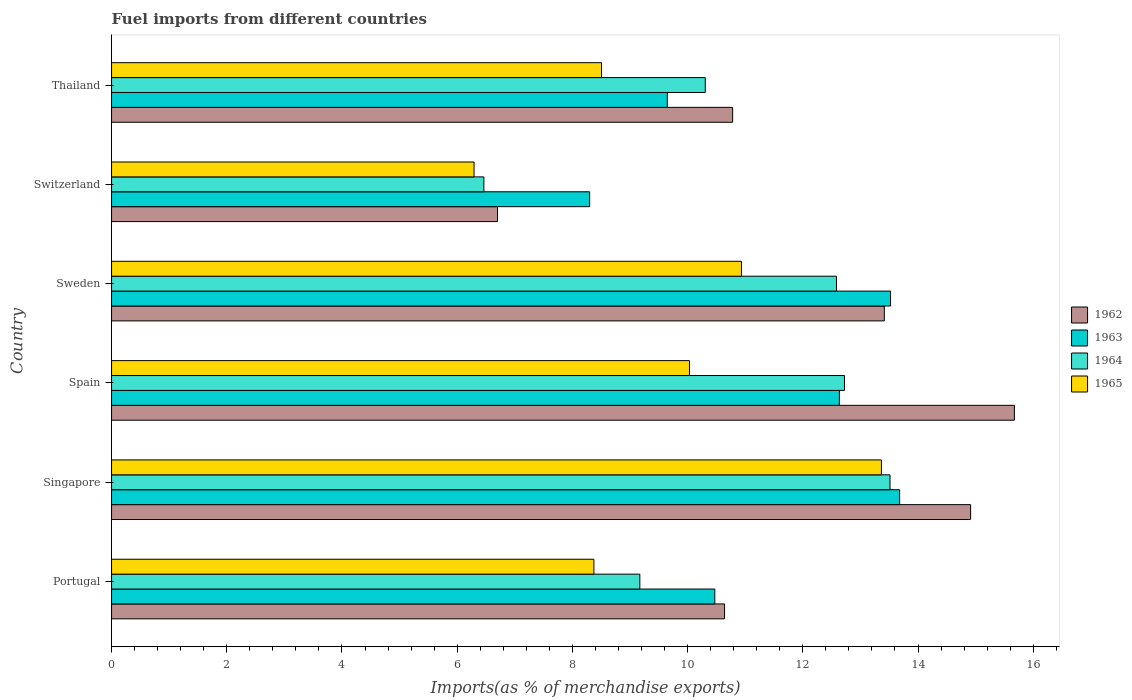How many different coloured bars are there?
Your answer should be compact. 4. Are the number of bars per tick equal to the number of legend labels?
Offer a terse response. Yes. How many bars are there on the 3rd tick from the top?
Offer a terse response. 4. How many bars are there on the 4th tick from the bottom?
Your answer should be compact. 4. What is the label of the 2nd group of bars from the top?
Your response must be concise. Switzerland. What is the percentage of imports to different countries in 1964 in Sweden?
Your response must be concise. 12.58. Across all countries, what is the maximum percentage of imports to different countries in 1962?
Your answer should be very brief. 15.67. Across all countries, what is the minimum percentage of imports to different countries in 1965?
Your answer should be very brief. 6.29. In which country was the percentage of imports to different countries in 1964 maximum?
Provide a short and direct response. Singapore. In which country was the percentage of imports to different countries in 1962 minimum?
Ensure brevity in your answer.  Switzerland. What is the total percentage of imports to different countries in 1964 in the graph?
Give a very brief answer. 64.76. What is the difference between the percentage of imports to different countries in 1963 in Portugal and that in Singapore?
Make the answer very short. -3.21. What is the difference between the percentage of imports to different countries in 1965 in Switzerland and the percentage of imports to different countries in 1964 in Singapore?
Offer a very short reply. -7.22. What is the average percentage of imports to different countries in 1962 per country?
Ensure brevity in your answer.  12.02. What is the difference between the percentage of imports to different countries in 1964 and percentage of imports to different countries in 1963 in Switzerland?
Keep it short and to the point. -1.84. In how many countries, is the percentage of imports to different countries in 1962 greater than 7.2 %?
Offer a very short reply. 5. What is the ratio of the percentage of imports to different countries in 1964 in Singapore to that in Thailand?
Give a very brief answer. 1.31. What is the difference between the highest and the second highest percentage of imports to different countries in 1965?
Provide a succinct answer. 2.43. What is the difference between the highest and the lowest percentage of imports to different countries in 1965?
Keep it short and to the point. 7.07. What does the 4th bar from the bottom in Sweden represents?
Your response must be concise. 1965. Is it the case that in every country, the sum of the percentage of imports to different countries in 1963 and percentage of imports to different countries in 1965 is greater than the percentage of imports to different countries in 1962?
Make the answer very short. Yes. Are all the bars in the graph horizontal?
Keep it short and to the point. Yes. Does the graph contain any zero values?
Offer a terse response. No. Does the graph contain grids?
Offer a terse response. No. Where does the legend appear in the graph?
Offer a very short reply. Center right. What is the title of the graph?
Keep it short and to the point. Fuel imports from different countries. Does "2003" appear as one of the legend labels in the graph?
Your answer should be compact. No. What is the label or title of the X-axis?
Offer a very short reply. Imports(as % of merchandise exports). What is the label or title of the Y-axis?
Keep it short and to the point. Country. What is the Imports(as % of merchandise exports) in 1962 in Portugal?
Your answer should be compact. 10.64. What is the Imports(as % of merchandise exports) of 1963 in Portugal?
Offer a very short reply. 10.47. What is the Imports(as % of merchandise exports) in 1964 in Portugal?
Ensure brevity in your answer.  9.17. What is the Imports(as % of merchandise exports) in 1965 in Portugal?
Offer a very short reply. 8.37. What is the Imports(as % of merchandise exports) of 1962 in Singapore?
Give a very brief answer. 14.91. What is the Imports(as % of merchandise exports) of 1963 in Singapore?
Your response must be concise. 13.68. What is the Imports(as % of merchandise exports) in 1964 in Singapore?
Provide a short and direct response. 13.51. What is the Imports(as % of merchandise exports) of 1965 in Singapore?
Provide a succinct answer. 13.37. What is the Imports(as % of merchandise exports) in 1962 in Spain?
Offer a very short reply. 15.67. What is the Imports(as % of merchandise exports) in 1963 in Spain?
Give a very brief answer. 12.64. What is the Imports(as % of merchandise exports) in 1964 in Spain?
Your answer should be very brief. 12.72. What is the Imports(as % of merchandise exports) in 1965 in Spain?
Your answer should be very brief. 10.03. What is the Imports(as % of merchandise exports) in 1962 in Sweden?
Your answer should be compact. 13.42. What is the Imports(as % of merchandise exports) in 1963 in Sweden?
Ensure brevity in your answer.  13.52. What is the Imports(as % of merchandise exports) of 1964 in Sweden?
Provide a short and direct response. 12.58. What is the Imports(as % of merchandise exports) of 1965 in Sweden?
Ensure brevity in your answer.  10.93. What is the Imports(as % of merchandise exports) in 1962 in Switzerland?
Give a very brief answer. 6.7. What is the Imports(as % of merchandise exports) of 1963 in Switzerland?
Provide a short and direct response. 8.3. What is the Imports(as % of merchandise exports) of 1964 in Switzerland?
Keep it short and to the point. 6.46. What is the Imports(as % of merchandise exports) of 1965 in Switzerland?
Provide a short and direct response. 6.29. What is the Imports(as % of merchandise exports) of 1962 in Thailand?
Keep it short and to the point. 10.78. What is the Imports(as % of merchandise exports) in 1963 in Thailand?
Your response must be concise. 9.65. What is the Imports(as % of merchandise exports) in 1964 in Thailand?
Offer a terse response. 10.31. What is the Imports(as % of merchandise exports) in 1965 in Thailand?
Give a very brief answer. 8.51. Across all countries, what is the maximum Imports(as % of merchandise exports) of 1962?
Offer a very short reply. 15.67. Across all countries, what is the maximum Imports(as % of merchandise exports) of 1963?
Provide a succinct answer. 13.68. Across all countries, what is the maximum Imports(as % of merchandise exports) in 1964?
Offer a terse response. 13.51. Across all countries, what is the maximum Imports(as % of merchandise exports) of 1965?
Offer a very short reply. 13.37. Across all countries, what is the minimum Imports(as % of merchandise exports) in 1962?
Offer a very short reply. 6.7. Across all countries, what is the minimum Imports(as % of merchandise exports) in 1963?
Provide a short and direct response. 8.3. Across all countries, what is the minimum Imports(as % of merchandise exports) of 1964?
Your answer should be compact. 6.46. Across all countries, what is the minimum Imports(as % of merchandise exports) of 1965?
Make the answer very short. 6.29. What is the total Imports(as % of merchandise exports) in 1962 in the graph?
Offer a very short reply. 72.13. What is the total Imports(as % of merchandise exports) in 1963 in the graph?
Your answer should be very brief. 68.26. What is the total Imports(as % of merchandise exports) of 1964 in the graph?
Your answer should be compact. 64.76. What is the total Imports(as % of merchandise exports) in 1965 in the graph?
Ensure brevity in your answer.  57.51. What is the difference between the Imports(as % of merchandise exports) of 1962 in Portugal and that in Singapore?
Offer a terse response. -4.27. What is the difference between the Imports(as % of merchandise exports) in 1963 in Portugal and that in Singapore?
Your answer should be very brief. -3.21. What is the difference between the Imports(as % of merchandise exports) in 1964 in Portugal and that in Singapore?
Provide a succinct answer. -4.34. What is the difference between the Imports(as % of merchandise exports) of 1965 in Portugal and that in Singapore?
Make the answer very short. -4.99. What is the difference between the Imports(as % of merchandise exports) of 1962 in Portugal and that in Spain?
Provide a short and direct response. -5.03. What is the difference between the Imports(as % of merchandise exports) in 1963 in Portugal and that in Spain?
Your answer should be compact. -2.16. What is the difference between the Imports(as % of merchandise exports) of 1964 in Portugal and that in Spain?
Offer a terse response. -3.55. What is the difference between the Imports(as % of merchandise exports) in 1965 in Portugal and that in Spain?
Your response must be concise. -1.66. What is the difference between the Imports(as % of merchandise exports) in 1962 in Portugal and that in Sweden?
Provide a short and direct response. -2.77. What is the difference between the Imports(as % of merchandise exports) in 1963 in Portugal and that in Sweden?
Give a very brief answer. -3.05. What is the difference between the Imports(as % of merchandise exports) in 1964 in Portugal and that in Sweden?
Your response must be concise. -3.41. What is the difference between the Imports(as % of merchandise exports) in 1965 in Portugal and that in Sweden?
Give a very brief answer. -2.56. What is the difference between the Imports(as % of merchandise exports) in 1962 in Portugal and that in Switzerland?
Provide a short and direct response. 3.94. What is the difference between the Imports(as % of merchandise exports) of 1963 in Portugal and that in Switzerland?
Offer a very short reply. 2.17. What is the difference between the Imports(as % of merchandise exports) in 1964 in Portugal and that in Switzerland?
Make the answer very short. 2.71. What is the difference between the Imports(as % of merchandise exports) in 1965 in Portugal and that in Switzerland?
Ensure brevity in your answer.  2.08. What is the difference between the Imports(as % of merchandise exports) of 1962 in Portugal and that in Thailand?
Offer a terse response. -0.14. What is the difference between the Imports(as % of merchandise exports) in 1963 in Portugal and that in Thailand?
Provide a succinct answer. 0.82. What is the difference between the Imports(as % of merchandise exports) of 1964 in Portugal and that in Thailand?
Ensure brevity in your answer.  -1.14. What is the difference between the Imports(as % of merchandise exports) of 1965 in Portugal and that in Thailand?
Keep it short and to the point. -0.13. What is the difference between the Imports(as % of merchandise exports) in 1962 in Singapore and that in Spain?
Your answer should be very brief. -0.76. What is the difference between the Imports(as % of merchandise exports) in 1963 in Singapore and that in Spain?
Provide a short and direct response. 1.05. What is the difference between the Imports(as % of merchandise exports) of 1964 in Singapore and that in Spain?
Give a very brief answer. 0.79. What is the difference between the Imports(as % of merchandise exports) in 1965 in Singapore and that in Spain?
Your response must be concise. 3.33. What is the difference between the Imports(as % of merchandise exports) in 1962 in Singapore and that in Sweden?
Ensure brevity in your answer.  1.5. What is the difference between the Imports(as % of merchandise exports) in 1963 in Singapore and that in Sweden?
Offer a very short reply. 0.16. What is the difference between the Imports(as % of merchandise exports) in 1964 in Singapore and that in Sweden?
Give a very brief answer. 0.93. What is the difference between the Imports(as % of merchandise exports) in 1965 in Singapore and that in Sweden?
Keep it short and to the point. 2.43. What is the difference between the Imports(as % of merchandise exports) in 1962 in Singapore and that in Switzerland?
Your response must be concise. 8.21. What is the difference between the Imports(as % of merchandise exports) in 1963 in Singapore and that in Switzerland?
Provide a succinct answer. 5.38. What is the difference between the Imports(as % of merchandise exports) of 1964 in Singapore and that in Switzerland?
Your answer should be very brief. 7.05. What is the difference between the Imports(as % of merchandise exports) of 1965 in Singapore and that in Switzerland?
Make the answer very short. 7.07. What is the difference between the Imports(as % of merchandise exports) of 1962 in Singapore and that in Thailand?
Provide a short and direct response. 4.13. What is the difference between the Imports(as % of merchandise exports) of 1963 in Singapore and that in Thailand?
Make the answer very short. 4.03. What is the difference between the Imports(as % of merchandise exports) of 1964 in Singapore and that in Thailand?
Your answer should be compact. 3.21. What is the difference between the Imports(as % of merchandise exports) in 1965 in Singapore and that in Thailand?
Ensure brevity in your answer.  4.86. What is the difference between the Imports(as % of merchandise exports) in 1962 in Spain and that in Sweden?
Provide a short and direct response. 2.26. What is the difference between the Imports(as % of merchandise exports) of 1963 in Spain and that in Sweden?
Your response must be concise. -0.89. What is the difference between the Imports(as % of merchandise exports) in 1964 in Spain and that in Sweden?
Ensure brevity in your answer.  0.14. What is the difference between the Imports(as % of merchandise exports) of 1965 in Spain and that in Sweden?
Make the answer very short. -0.9. What is the difference between the Imports(as % of merchandise exports) of 1962 in Spain and that in Switzerland?
Make the answer very short. 8.97. What is the difference between the Imports(as % of merchandise exports) in 1963 in Spain and that in Switzerland?
Provide a short and direct response. 4.34. What is the difference between the Imports(as % of merchandise exports) of 1964 in Spain and that in Switzerland?
Ensure brevity in your answer.  6.26. What is the difference between the Imports(as % of merchandise exports) of 1965 in Spain and that in Switzerland?
Keep it short and to the point. 3.74. What is the difference between the Imports(as % of merchandise exports) in 1962 in Spain and that in Thailand?
Offer a very short reply. 4.89. What is the difference between the Imports(as % of merchandise exports) in 1963 in Spain and that in Thailand?
Provide a succinct answer. 2.99. What is the difference between the Imports(as % of merchandise exports) of 1964 in Spain and that in Thailand?
Offer a terse response. 2.42. What is the difference between the Imports(as % of merchandise exports) of 1965 in Spain and that in Thailand?
Make the answer very short. 1.53. What is the difference between the Imports(as % of merchandise exports) in 1962 in Sweden and that in Switzerland?
Keep it short and to the point. 6.72. What is the difference between the Imports(as % of merchandise exports) in 1963 in Sweden and that in Switzerland?
Give a very brief answer. 5.22. What is the difference between the Imports(as % of merchandise exports) of 1964 in Sweden and that in Switzerland?
Make the answer very short. 6.12. What is the difference between the Imports(as % of merchandise exports) of 1965 in Sweden and that in Switzerland?
Your answer should be very brief. 4.64. What is the difference between the Imports(as % of merchandise exports) in 1962 in Sweden and that in Thailand?
Offer a very short reply. 2.63. What is the difference between the Imports(as % of merchandise exports) in 1963 in Sweden and that in Thailand?
Your answer should be very brief. 3.88. What is the difference between the Imports(as % of merchandise exports) in 1964 in Sweden and that in Thailand?
Offer a very short reply. 2.28. What is the difference between the Imports(as % of merchandise exports) in 1965 in Sweden and that in Thailand?
Keep it short and to the point. 2.43. What is the difference between the Imports(as % of merchandise exports) of 1962 in Switzerland and that in Thailand?
Make the answer very short. -4.08. What is the difference between the Imports(as % of merchandise exports) in 1963 in Switzerland and that in Thailand?
Provide a short and direct response. -1.35. What is the difference between the Imports(as % of merchandise exports) in 1964 in Switzerland and that in Thailand?
Provide a succinct answer. -3.84. What is the difference between the Imports(as % of merchandise exports) in 1965 in Switzerland and that in Thailand?
Offer a terse response. -2.21. What is the difference between the Imports(as % of merchandise exports) of 1962 in Portugal and the Imports(as % of merchandise exports) of 1963 in Singapore?
Your response must be concise. -3.04. What is the difference between the Imports(as % of merchandise exports) in 1962 in Portugal and the Imports(as % of merchandise exports) in 1964 in Singapore?
Keep it short and to the point. -2.87. What is the difference between the Imports(as % of merchandise exports) of 1962 in Portugal and the Imports(as % of merchandise exports) of 1965 in Singapore?
Give a very brief answer. -2.72. What is the difference between the Imports(as % of merchandise exports) in 1963 in Portugal and the Imports(as % of merchandise exports) in 1964 in Singapore?
Make the answer very short. -3.04. What is the difference between the Imports(as % of merchandise exports) in 1963 in Portugal and the Imports(as % of merchandise exports) in 1965 in Singapore?
Offer a very short reply. -2.89. What is the difference between the Imports(as % of merchandise exports) in 1964 in Portugal and the Imports(as % of merchandise exports) in 1965 in Singapore?
Provide a short and direct response. -4.19. What is the difference between the Imports(as % of merchandise exports) of 1962 in Portugal and the Imports(as % of merchandise exports) of 1963 in Spain?
Your answer should be very brief. -1.99. What is the difference between the Imports(as % of merchandise exports) of 1962 in Portugal and the Imports(as % of merchandise exports) of 1964 in Spain?
Keep it short and to the point. -2.08. What is the difference between the Imports(as % of merchandise exports) of 1962 in Portugal and the Imports(as % of merchandise exports) of 1965 in Spain?
Offer a terse response. 0.61. What is the difference between the Imports(as % of merchandise exports) of 1963 in Portugal and the Imports(as % of merchandise exports) of 1964 in Spain?
Your response must be concise. -2.25. What is the difference between the Imports(as % of merchandise exports) of 1963 in Portugal and the Imports(as % of merchandise exports) of 1965 in Spain?
Give a very brief answer. 0.44. What is the difference between the Imports(as % of merchandise exports) of 1964 in Portugal and the Imports(as % of merchandise exports) of 1965 in Spain?
Keep it short and to the point. -0.86. What is the difference between the Imports(as % of merchandise exports) of 1962 in Portugal and the Imports(as % of merchandise exports) of 1963 in Sweden?
Provide a short and direct response. -2.88. What is the difference between the Imports(as % of merchandise exports) of 1962 in Portugal and the Imports(as % of merchandise exports) of 1964 in Sweden?
Your response must be concise. -1.94. What is the difference between the Imports(as % of merchandise exports) of 1962 in Portugal and the Imports(as % of merchandise exports) of 1965 in Sweden?
Provide a succinct answer. -0.29. What is the difference between the Imports(as % of merchandise exports) of 1963 in Portugal and the Imports(as % of merchandise exports) of 1964 in Sweden?
Ensure brevity in your answer.  -2.11. What is the difference between the Imports(as % of merchandise exports) in 1963 in Portugal and the Imports(as % of merchandise exports) in 1965 in Sweden?
Provide a short and direct response. -0.46. What is the difference between the Imports(as % of merchandise exports) of 1964 in Portugal and the Imports(as % of merchandise exports) of 1965 in Sweden?
Offer a terse response. -1.76. What is the difference between the Imports(as % of merchandise exports) in 1962 in Portugal and the Imports(as % of merchandise exports) in 1963 in Switzerland?
Your response must be concise. 2.34. What is the difference between the Imports(as % of merchandise exports) in 1962 in Portugal and the Imports(as % of merchandise exports) in 1964 in Switzerland?
Your answer should be compact. 4.18. What is the difference between the Imports(as % of merchandise exports) of 1962 in Portugal and the Imports(as % of merchandise exports) of 1965 in Switzerland?
Ensure brevity in your answer.  4.35. What is the difference between the Imports(as % of merchandise exports) in 1963 in Portugal and the Imports(as % of merchandise exports) in 1964 in Switzerland?
Your answer should be very brief. 4.01. What is the difference between the Imports(as % of merchandise exports) in 1963 in Portugal and the Imports(as % of merchandise exports) in 1965 in Switzerland?
Provide a succinct answer. 4.18. What is the difference between the Imports(as % of merchandise exports) in 1964 in Portugal and the Imports(as % of merchandise exports) in 1965 in Switzerland?
Offer a very short reply. 2.88. What is the difference between the Imports(as % of merchandise exports) in 1962 in Portugal and the Imports(as % of merchandise exports) in 1964 in Thailand?
Ensure brevity in your answer.  0.33. What is the difference between the Imports(as % of merchandise exports) of 1962 in Portugal and the Imports(as % of merchandise exports) of 1965 in Thailand?
Provide a short and direct response. 2.14. What is the difference between the Imports(as % of merchandise exports) in 1963 in Portugal and the Imports(as % of merchandise exports) in 1964 in Thailand?
Provide a succinct answer. 0.17. What is the difference between the Imports(as % of merchandise exports) of 1963 in Portugal and the Imports(as % of merchandise exports) of 1965 in Thailand?
Keep it short and to the point. 1.97. What is the difference between the Imports(as % of merchandise exports) of 1964 in Portugal and the Imports(as % of merchandise exports) of 1965 in Thailand?
Make the answer very short. 0.66. What is the difference between the Imports(as % of merchandise exports) of 1962 in Singapore and the Imports(as % of merchandise exports) of 1963 in Spain?
Ensure brevity in your answer.  2.28. What is the difference between the Imports(as % of merchandise exports) in 1962 in Singapore and the Imports(as % of merchandise exports) in 1964 in Spain?
Your answer should be compact. 2.19. What is the difference between the Imports(as % of merchandise exports) of 1962 in Singapore and the Imports(as % of merchandise exports) of 1965 in Spain?
Provide a succinct answer. 4.88. What is the difference between the Imports(as % of merchandise exports) in 1963 in Singapore and the Imports(as % of merchandise exports) in 1964 in Spain?
Your answer should be compact. 0.96. What is the difference between the Imports(as % of merchandise exports) of 1963 in Singapore and the Imports(as % of merchandise exports) of 1965 in Spain?
Provide a short and direct response. 3.65. What is the difference between the Imports(as % of merchandise exports) of 1964 in Singapore and the Imports(as % of merchandise exports) of 1965 in Spain?
Offer a terse response. 3.48. What is the difference between the Imports(as % of merchandise exports) of 1962 in Singapore and the Imports(as % of merchandise exports) of 1963 in Sweden?
Your answer should be very brief. 1.39. What is the difference between the Imports(as % of merchandise exports) in 1962 in Singapore and the Imports(as % of merchandise exports) in 1964 in Sweden?
Your answer should be compact. 2.33. What is the difference between the Imports(as % of merchandise exports) in 1962 in Singapore and the Imports(as % of merchandise exports) in 1965 in Sweden?
Give a very brief answer. 3.98. What is the difference between the Imports(as % of merchandise exports) of 1963 in Singapore and the Imports(as % of merchandise exports) of 1964 in Sweden?
Offer a very short reply. 1.1. What is the difference between the Imports(as % of merchandise exports) of 1963 in Singapore and the Imports(as % of merchandise exports) of 1965 in Sweden?
Offer a terse response. 2.75. What is the difference between the Imports(as % of merchandise exports) of 1964 in Singapore and the Imports(as % of merchandise exports) of 1965 in Sweden?
Provide a short and direct response. 2.58. What is the difference between the Imports(as % of merchandise exports) in 1962 in Singapore and the Imports(as % of merchandise exports) in 1963 in Switzerland?
Offer a very short reply. 6.61. What is the difference between the Imports(as % of merchandise exports) of 1962 in Singapore and the Imports(as % of merchandise exports) of 1964 in Switzerland?
Offer a terse response. 8.45. What is the difference between the Imports(as % of merchandise exports) of 1962 in Singapore and the Imports(as % of merchandise exports) of 1965 in Switzerland?
Offer a very short reply. 8.62. What is the difference between the Imports(as % of merchandise exports) of 1963 in Singapore and the Imports(as % of merchandise exports) of 1964 in Switzerland?
Ensure brevity in your answer.  7.22. What is the difference between the Imports(as % of merchandise exports) in 1963 in Singapore and the Imports(as % of merchandise exports) in 1965 in Switzerland?
Your answer should be compact. 7.39. What is the difference between the Imports(as % of merchandise exports) of 1964 in Singapore and the Imports(as % of merchandise exports) of 1965 in Switzerland?
Ensure brevity in your answer.  7.22. What is the difference between the Imports(as % of merchandise exports) of 1962 in Singapore and the Imports(as % of merchandise exports) of 1963 in Thailand?
Ensure brevity in your answer.  5.27. What is the difference between the Imports(as % of merchandise exports) of 1962 in Singapore and the Imports(as % of merchandise exports) of 1964 in Thailand?
Give a very brief answer. 4.61. What is the difference between the Imports(as % of merchandise exports) of 1962 in Singapore and the Imports(as % of merchandise exports) of 1965 in Thailand?
Your answer should be very brief. 6.41. What is the difference between the Imports(as % of merchandise exports) in 1963 in Singapore and the Imports(as % of merchandise exports) in 1964 in Thailand?
Your response must be concise. 3.37. What is the difference between the Imports(as % of merchandise exports) of 1963 in Singapore and the Imports(as % of merchandise exports) of 1965 in Thailand?
Your answer should be compact. 5.18. What is the difference between the Imports(as % of merchandise exports) of 1964 in Singapore and the Imports(as % of merchandise exports) of 1965 in Thailand?
Offer a very short reply. 5.01. What is the difference between the Imports(as % of merchandise exports) of 1962 in Spain and the Imports(as % of merchandise exports) of 1963 in Sweden?
Make the answer very short. 2.15. What is the difference between the Imports(as % of merchandise exports) of 1962 in Spain and the Imports(as % of merchandise exports) of 1964 in Sweden?
Make the answer very short. 3.09. What is the difference between the Imports(as % of merchandise exports) of 1962 in Spain and the Imports(as % of merchandise exports) of 1965 in Sweden?
Offer a terse response. 4.74. What is the difference between the Imports(as % of merchandise exports) in 1963 in Spain and the Imports(as % of merchandise exports) in 1964 in Sweden?
Your answer should be compact. 0.05. What is the difference between the Imports(as % of merchandise exports) in 1963 in Spain and the Imports(as % of merchandise exports) in 1965 in Sweden?
Ensure brevity in your answer.  1.7. What is the difference between the Imports(as % of merchandise exports) in 1964 in Spain and the Imports(as % of merchandise exports) in 1965 in Sweden?
Keep it short and to the point. 1.79. What is the difference between the Imports(as % of merchandise exports) in 1962 in Spain and the Imports(as % of merchandise exports) in 1963 in Switzerland?
Your response must be concise. 7.37. What is the difference between the Imports(as % of merchandise exports) in 1962 in Spain and the Imports(as % of merchandise exports) in 1964 in Switzerland?
Ensure brevity in your answer.  9.21. What is the difference between the Imports(as % of merchandise exports) in 1962 in Spain and the Imports(as % of merchandise exports) in 1965 in Switzerland?
Offer a very short reply. 9.38. What is the difference between the Imports(as % of merchandise exports) of 1963 in Spain and the Imports(as % of merchandise exports) of 1964 in Switzerland?
Keep it short and to the point. 6.17. What is the difference between the Imports(as % of merchandise exports) in 1963 in Spain and the Imports(as % of merchandise exports) in 1965 in Switzerland?
Keep it short and to the point. 6.34. What is the difference between the Imports(as % of merchandise exports) of 1964 in Spain and the Imports(as % of merchandise exports) of 1965 in Switzerland?
Your answer should be very brief. 6.43. What is the difference between the Imports(as % of merchandise exports) of 1962 in Spain and the Imports(as % of merchandise exports) of 1963 in Thailand?
Make the answer very short. 6.03. What is the difference between the Imports(as % of merchandise exports) in 1962 in Spain and the Imports(as % of merchandise exports) in 1964 in Thailand?
Your response must be concise. 5.37. What is the difference between the Imports(as % of merchandise exports) in 1962 in Spain and the Imports(as % of merchandise exports) in 1965 in Thailand?
Offer a terse response. 7.17. What is the difference between the Imports(as % of merchandise exports) of 1963 in Spain and the Imports(as % of merchandise exports) of 1964 in Thailand?
Offer a terse response. 2.33. What is the difference between the Imports(as % of merchandise exports) in 1963 in Spain and the Imports(as % of merchandise exports) in 1965 in Thailand?
Your answer should be very brief. 4.13. What is the difference between the Imports(as % of merchandise exports) in 1964 in Spain and the Imports(as % of merchandise exports) in 1965 in Thailand?
Keep it short and to the point. 4.22. What is the difference between the Imports(as % of merchandise exports) in 1962 in Sweden and the Imports(as % of merchandise exports) in 1963 in Switzerland?
Provide a succinct answer. 5.12. What is the difference between the Imports(as % of merchandise exports) in 1962 in Sweden and the Imports(as % of merchandise exports) in 1964 in Switzerland?
Keep it short and to the point. 6.95. What is the difference between the Imports(as % of merchandise exports) in 1962 in Sweden and the Imports(as % of merchandise exports) in 1965 in Switzerland?
Your answer should be compact. 7.12. What is the difference between the Imports(as % of merchandise exports) of 1963 in Sweden and the Imports(as % of merchandise exports) of 1964 in Switzerland?
Give a very brief answer. 7.06. What is the difference between the Imports(as % of merchandise exports) in 1963 in Sweden and the Imports(as % of merchandise exports) in 1965 in Switzerland?
Give a very brief answer. 7.23. What is the difference between the Imports(as % of merchandise exports) in 1964 in Sweden and the Imports(as % of merchandise exports) in 1965 in Switzerland?
Offer a very short reply. 6.29. What is the difference between the Imports(as % of merchandise exports) in 1962 in Sweden and the Imports(as % of merchandise exports) in 1963 in Thailand?
Offer a terse response. 3.77. What is the difference between the Imports(as % of merchandise exports) in 1962 in Sweden and the Imports(as % of merchandise exports) in 1964 in Thailand?
Your answer should be very brief. 3.11. What is the difference between the Imports(as % of merchandise exports) in 1962 in Sweden and the Imports(as % of merchandise exports) in 1965 in Thailand?
Keep it short and to the point. 4.91. What is the difference between the Imports(as % of merchandise exports) of 1963 in Sweden and the Imports(as % of merchandise exports) of 1964 in Thailand?
Offer a terse response. 3.22. What is the difference between the Imports(as % of merchandise exports) of 1963 in Sweden and the Imports(as % of merchandise exports) of 1965 in Thailand?
Your response must be concise. 5.02. What is the difference between the Imports(as % of merchandise exports) of 1964 in Sweden and the Imports(as % of merchandise exports) of 1965 in Thailand?
Your answer should be very brief. 4.08. What is the difference between the Imports(as % of merchandise exports) in 1962 in Switzerland and the Imports(as % of merchandise exports) in 1963 in Thailand?
Offer a very short reply. -2.95. What is the difference between the Imports(as % of merchandise exports) in 1962 in Switzerland and the Imports(as % of merchandise exports) in 1964 in Thailand?
Ensure brevity in your answer.  -3.61. What is the difference between the Imports(as % of merchandise exports) of 1962 in Switzerland and the Imports(as % of merchandise exports) of 1965 in Thailand?
Make the answer very short. -1.81. What is the difference between the Imports(as % of merchandise exports) of 1963 in Switzerland and the Imports(as % of merchandise exports) of 1964 in Thailand?
Give a very brief answer. -2.01. What is the difference between the Imports(as % of merchandise exports) in 1963 in Switzerland and the Imports(as % of merchandise exports) in 1965 in Thailand?
Your answer should be compact. -0.21. What is the difference between the Imports(as % of merchandise exports) of 1964 in Switzerland and the Imports(as % of merchandise exports) of 1965 in Thailand?
Your response must be concise. -2.04. What is the average Imports(as % of merchandise exports) of 1962 per country?
Offer a terse response. 12.02. What is the average Imports(as % of merchandise exports) in 1963 per country?
Provide a short and direct response. 11.38. What is the average Imports(as % of merchandise exports) in 1964 per country?
Make the answer very short. 10.79. What is the average Imports(as % of merchandise exports) in 1965 per country?
Give a very brief answer. 9.58. What is the difference between the Imports(as % of merchandise exports) in 1962 and Imports(as % of merchandise exports) in 1963 in Portugal?
Offer a terse response. 0.17. What is the difference between the Imports(as % of merchandise exports) in 1962 and Imports(as % of merchandise exports) in 1964 in Portugal?
Your answer should be compact. 1.47. What is the difference between the Imports(as % of merchandise exports) in 1962 and Imports(as % of merchandise exports) in 1965 in Portugal?
Your answer should be very brief. 2.27. What is the difference between the Imports(as % of merchandise exports) in 1963 and Imports(as % of merchandise exports) in 1964 in Portugal?
Give a very brief answer. 1.3. What is the difference between the Imports(as % of merchandise exports) in 1963 and Imports(as % of merchandise exports) in 1965 in Portugal?
Offer a very short reply. 2.1. What is the difference between the Imports(as % of merchandise exports) of 1964 and Imports(as % of merchandise exports) of 1965 in Portugal?
Offer a terse response. 0.8. What is the difference between the Imports(as % of merchandise exports) of 1962 and Imports(as % of merchandise exports) of 1963 in Singapore?
Provide a succinct answer. 1.23. What is the difference between the Imports(as % of merchandise exports) in 1962 and Imports(as % of merchandise exports) in 1964 in Singapore?
Give a very brief answer. 1.4. What is the difference between the Imports(as % of merchandise exports) of 1962 and Imports(as % of merchandise exports) of 1965 in Singapore?
Keep it short and to the point. 1.55. What is the difference between the Imports(as % of merchandise exports) of 1963 and Imports(as % of merchandise exports) of 1964 in Singapore?
Ensure brevity in your answer.  0.17. What is the difference between the Imports(as % of merchandise exports) in 1963 and Imports(as % of merchandise exports) in 1965 in Singapore?
Your response must be concise. 0.32. What is the difference between the Imports(as % of merchandise exports) of 1964 and Imports(as % of merchandise exports) of 1965 in Singapore?
Keep it short and to the point. 0.15. What is the difference between the Imports(as % of merchandise exports) of 1962 and Imports(as % of merchandise exports) of 1963 in Spain?
Offer a very short reply. 3.04. What is the difference between the Imports(as % of merchandise exports) of 1962 and Imports(as % of merchandise exports) of 1964 in Spain?
Provide a short and direct response. 2.95. What is the difference between the Imports(as % of merchandise exports) in 1962 and Imports(as % of merchandise exports) in 1965 in Spain?
Your answer should be very brief. 5.64. What is the difference between the Imports(as % of merchandise exports) in 1963 and Imports(as % of merchandise exports) in 1964 in Spain?
Your answer should be compact. -0.09. What is the difference between the Imports(as % of merchandise exports) of 1963 and Imports(as % of merchandise exports) of 1965 in Spain?
Keep it short and to the point. 2.6. What is the difference between the Imports(as % of merchandise exports) in 1964 and Imports(as % of merchandise exports) in 1965 in Spain?
Offer a terse response. 2.69. What is the difference between the Imports(as % of merchandise exports) of 1962 and Imports(as % of merchandise exports) of 1963 in Sweden?
Your response must be concise. -0.11. What is the difference between the Imports(as % of merchandise exports) in 1962 and Imports(as % of merchandise exports) in 1964 in Sweden?
Your answer should be compact. 0.83. What is the difference between the Imports(as % of merchandise exports) of 1962 and Imports(as % of merchandise exports) of 1965 in Sweden?
Your response must be concise. 2.48. What is the difference between the Imports(as % of merchandise exports) in 1963 and Imports(as % of merchandise exports) in 1964 in Sweden?
Your response must be concise. 0.94. What is the difference between the Imports(as % of merchandise exports) of 1963 and Imports(as % of merchandise exports) of 1965 in Sweden?
Your answer should be compact. 2.59. What is the difference between the Imports(as % of merchandise exports) in 1964 and Imports(as % of merchandise exports) in 1965 in Sweden?
Ensure brevity in your answer.  1.65. What is the difference between the Imports(as % of merchandise exports) in 1962 and Imports(as % of merchandise exports) in 1963 in Switzerland?
Make the answer very short. -1.6. What is the difference between the Imports(as % of merchandise exports) of 1962 and Imports(as % of merchandise exports) of 1964 in Switzerland?
Ensure brevity in your answer.  0.24. What is the difference between the Imports(as % of merchandise exports) in 1962 and Imports(as % of merchandise exports) in 1965 in Switzerland?
Your answer should be compact. 0.41. What is the difference between the Imports(as % of merchandise exports) in 1963 and Imports(as % of merchandise exports) in 1964 in Switzerland?
Offer a very short reply. 1.84. What is the difference between the Imports(as % of merchandise exports) of 1963 and Imports(as % of merchandise exports) of 1965 in Switzerland?
Your answer should be very brief. 2.01. What is the difference between the Imports(as % of merchandise exports) of 1964 and Imports(as % of merchandise exports) of 1965 in Switzerland?
Offer a terse response. 0.17. What is the difference between the Imports(as % of merchandise exports) in 1962 and Imports(as % of merchandise exports) in 1963 in Thailand?
Ensure brevity in your answer.  1.13. What is the difference between the Imports(as % of merchandise exports) of 1962 and Imports(as % of merchandise exports) of 1964 in Thailand?
Give a very brief answer. 0.48. What is the difference between the Imports(as % of merchandise exports) in 1962 and Imports(as % of merchandise exports) in 1965 in Thailand?
Provide a succinct answer. 2.28. What is the difference between the Imports(as % of merchandise exports) in 1963 and Imports(as % of merchandise exports) in 1964 in Thailand?
Ensure brevity in your answer.  -0.66. What is the difference between the Imports(as % of merchandise exports) of 1963 and Imports(as % of merchandise exports) of 1965 in Thailand?
Your response must be concise. 1.14. What is the difference between the Imports(as % of merchandise exports) of 1964 and Imports(as % of merchandise exports) of 1965 in Thailand?
Make the answer very short. 1.8. What is the ratio of the Imports(as % of merchandise exports) of 1962 in Portugal to that in Singapore?
Your response must be concise. 0.71. What is the ratio of the Imports(as % of merchandise exports) of 1963 in Portugal to that in Singapore?
Your answer should be compact. 0.77. What is the ratio of the Imports(as % of merchandise exports) of 1964 in Portugal to that in Singapore?
Provide a succinct answer. 0.68. What is the ratio of the Imports(as % of merchandise exports) of 1965 in Portugal to that in Singapore?
Your response must be concise. 0.63. What is the ratio of the Imports(as % of merchandise exports) in 1962 in Portugal to that in Spain?
Your response must be concise. 0.68. What is the ratio of the Imports(as % of merchandise exports) of 1963 in Portugal to that in Spain?
Your response must be concise. 0.83. What is the ratio of the Imports(as % of merchandise exports) of 1964 in Portugal to that in Spain?
Make the answer very short. 0.72. What is the ratio of the Imports(as % of merchandise exports) in 1965 in Portugal to that in Spain?
Offer a very short reply. 0.83. What is the ratio of the Imports(as % of merchandise exports) of 1962 in Portugal to that in Sweden?
Offer a very short reply. 0.79. What is the ratio of the Imports(as % of merchandise exports) of 1963 in Portugal to that in Sweden?
Give a very brief answer. 0.77. What is the ratio of the Imports(as % of merchandise exports) of 1964 in Portugal to that in Sweden?
Offer a very short reply. 0.73. What is the ratio of the Imports(as % of merchandise exports) of 1965 in Portugal to that in Sweden?
Keep it short and to the point. 0.77. What is the ratio of the Imports(as % of merchandise exports) in 1962 in Portugal to that in Switzerland?
Make the answer very short. 1.59. What is the ratio of the Imports(as % of merchandise exports) of 1963 in Portugal to that in Switzerland?
Provide a short and direct response. 1.26. What is the ratio of the Imports(as % of merchandise exports) of 1964 in Portugal to that in Switzerland?
Provide a short and direct response. 1.42. What is the ratio of the Imports(as % of merchandise exports) in 1965 in Portugal to that in Switzerland?
Make the answer very short. 1.33. What is the ratio of the Imports(as % of merchandise exports) of 1963 in Portugal to that in Thailand?
Your response must be concise. 1.09. What is the ratio of the Imports(as % of merchandise exports) of 1964 in Portugal to that in Thailand?
Give a very brief answer. 0.89. What is the ratio of the Imports(as % of merchandise exports) of 1965 in Portugal to that in Thailand?
Your answer should be very brief. 0.98. What is the ratio of the Imports(as % of merchandise exports) in 1962 in Singapore to that in Spain?
Provide a short and direct response. 0.95. What is the ratio of the Imports(as % of merchandise exports) in 1963 in Singapore to that in Spain?
Keep it short and to the point. 1.08. What is the ratio of the Imports(as % of merchandise exports) in 1964 in Singapore to that in Spain?
Your answer should be compact. 1.06. What is the ratio of the Imports(as % of merchandise exports) of 1965 in Singapore to that in Spain?
Ensure brevity in your answer.  1.33. What is the ratio of the Imports(as % of merchandise exports) in 1962 in Singapore to that in Sweden?
Keep it short and to the point. 1.11. What is the ratio of the Imports(as % of merchandise exports) of 1963 in Singapore to that in Sweden?
Provide a short and direct response. 1.01. What is the ratio of the Imports(as % of merchandise exports) in 1964 in Singapore to that in Sweden?
Ensure brevity in your answer.  1.07. What is the ratio of the Imports(as % of merchandise exports) of 1965 in Singapore to that in Sweden?
Offer a terse response. 1.22. What is the ratio of the Imports(as % of merchandise exports) in 1962 in Singapore to that in Switzerland?
Offer a very short reply. 2.23. What is the ratio of the Imports(as % of merchandise exports) of 1963 in Singapore to that in Switzerland?
Ensure brevity in your answer.  1.65. What is the ratio of the Imports(as % of merchandise exports) in 1964 in Singapore to that in Switzerland?
Offer a terse response. 2.09. What is the ratio of the Imports(as % of merchandise exports) of 1965 in Singapore to that in Switzerland?
Provide a short and direct response. 2.12. What is the ratio of the Imports(as % of merchandise exports) in 1962 in Singapore to that in Thailand?
Make the answer very short. 1.38. What is the ratio of the Imports(as % of merchandise exports) in 1963 in Singapore to that in Thailand?
Provide a succinct answer. 1.42. What is the ratio of the Imports(as % of merchandise exports) in 1964 in Singapore to that in Thailand?
Your answer should be compact. 1.31. What is the ratio of the Imports(as % of merchandise exports) of 1965 in Singapore to that in Thailand?
Give a very brief answer. 1.57. What is the ratio of the Imports(as % of merchandise exports) in 1962 in Spain to that in Sweden?
Make the answer very short. 1.17. What is the ratio of the Imports(as % of merchandise exports) in 1963 in Spain to that in Sweden?
Offer a terse response. 0.93. What is the ratio of the Imports(as % of merchandise exports) in 1965 in Spain to that in Sweden?
Provide a short and direct response. 0.92. What is the ratio of the Imports(as % of merchandise exports) in 1962 in Spain to that in Switzerland?
Provide a short and direct response. 2.34. What is the ratio of the Imports(as % of merchandise exports) of 1963 in Spain to that in Switzerland?
Provide a succinct answer. 1.52. What is the ratio of the Imports(as % of merchandise exports) in 1964 in Spain to that in Switzerland?
Your response must be concise. 1.97. What is the ratio of the Imports(as % of merchandise exports) of 1965 in Spain to that in Switzerland?
Offer a very short reply. 1.59. What is the ratio of the Imports(as % of merchandise exports) of 1962 in Spain to that in Thailand?
Your answer should be very brief. 1.45. What is the ratio of the Imports(as % of merchandise exports) in 1963 in Spain to that in Thailand?
Keep it short and to the point. 1.31. What is the ratio of the Imports(as % of merchandise exports) in 1964 in Spain to that in Thailand?
Provide a succinct answer. 1.23. What is the ratio of the Imports(as % of merchandise exports) in 1965 in Spain to that in Thailand?
Offer a terse response. 1.18. What is the ratio of the Imports(as % of merchandise exports) of 1962 in Sweden to that in Switzerland?
Offer a terse response. 2. What is the ratio of the Imports(as % of merchandise exports) in 1963 in Sweden to that in Switzerland?
Provide a succinct answer. 1.63. What is the ratio of the Imports(as % of merchandise exports) in 1964 in Sweden to that in Switzerland?
Your answer should be compact. 1.95. What is the ratio of the Imports(as % of merchandise exports) of 1965 in Sweden to that in Switzerland?
Offer a very short reply. 1.74. What is the ratio of the Imports(as % of merchandise exports) in 1962 in Sweden to that in Thailand?
Your response must be concise. 1.24. What is the ratio of the Imports(as % of merchandise exports) in 1963 in Sweden to that in Thailand?
Offer a terse response. 1.4. What is the ratio of the Imports(as % of merchandise exports) in 1964 in Sweden to that in Thailand?
Offer a terse response. 1.22. What is the ratio of the Imports(as % of merchandise exports) in 1965 in Sweden to that in Thailand?
Keep it short and to the point. 1.29. What is the ratio of the Imports(as % of merchandise exports) of 1962 in Switzerland to that in Thailand?
Give a very brief answer. 0.62. What is the ratio of the Imports(as % of merchandise exports) of 1963 in Switzerland to that in Thailand?
Offer a very short reply. 0.86. What is the ratio of the Imports(as % of merchandise exports) in 1964 in Switzerland to that in Thailand?
Your answer should be very brief. 0.63. What is the ratio of the Imports(as % of merchandise exports) in 1965 in Switzerland to that in Thailand?
Make the answer very short. 0.74. What is the difference between the highest and the second highest Imports(as % of merchandise exports) in 1962?
Provide a short and direct response. 0.76. What is the difference between the highest and the second highest Imports(as % of merchandise exports) of 1963?
Offer a very short reply. 0.16. What is the difference between the highest and the second highest Imports(as % of merchandise exports) of 1964?
Keep it short and to the point. 0.79. What is the difference between the highest and the second highest Imports(as % of merchandise exports) of 1965?
Your answer should be compact. 2.43. What is the difference between the highest and the lowest Imports(as % of merchandise exports) in 1962?
Your answer should be compact. 8.97. What is the difference between the highest and the lowest Imports(as % of merchandise exports) in 1963?
Your answer should be very brief. 5.38. What is the difference between the highest and the lowest Imports(as % of merchandise exports) in 1964?
Provide a succinct answer. 7.05. What is the difference between the highest and the lowest Imports(as % of merchandise exports) of 1965?
Your response must be concise. 7.07. 